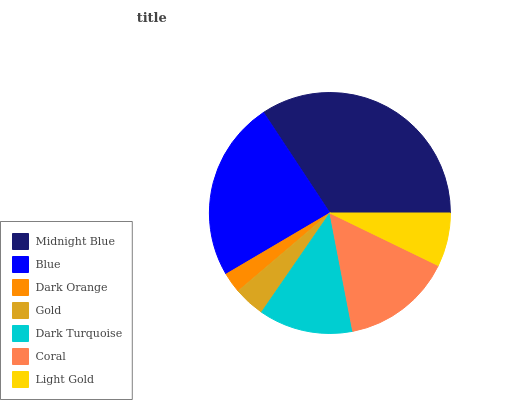Is Dark Orange the minimum?
Answer yes or no. Yes. Is Midnight Blue the maximum?
Answer yes or no. Yes. Is Blue the minimum?
Answer yes or no. No. Is Blue the maximum?
Answer yes or no. No. Is Midnight Blue greater than Blue?
Answer yes or no. Yes. Is Blue less than Midnight Blue?
Answer yes or no. Yes. Is Blue greater than Midnight Blue?
Answer yes or no. No. Is Midnight Blue less than Blue?
Answer yes or no. No. Is Dark Turquoise the high median?
Answer yes or no. Yes. Is Dark Turquoise the low median?
Answer yes or no. Yes. Is Blue the high median?
Answer yes or no. No. Is Dark Orange the low median?
Answer yes or no. No. 